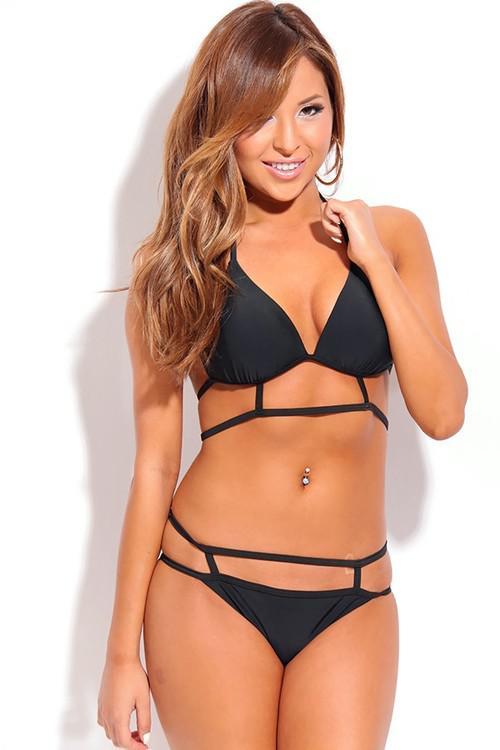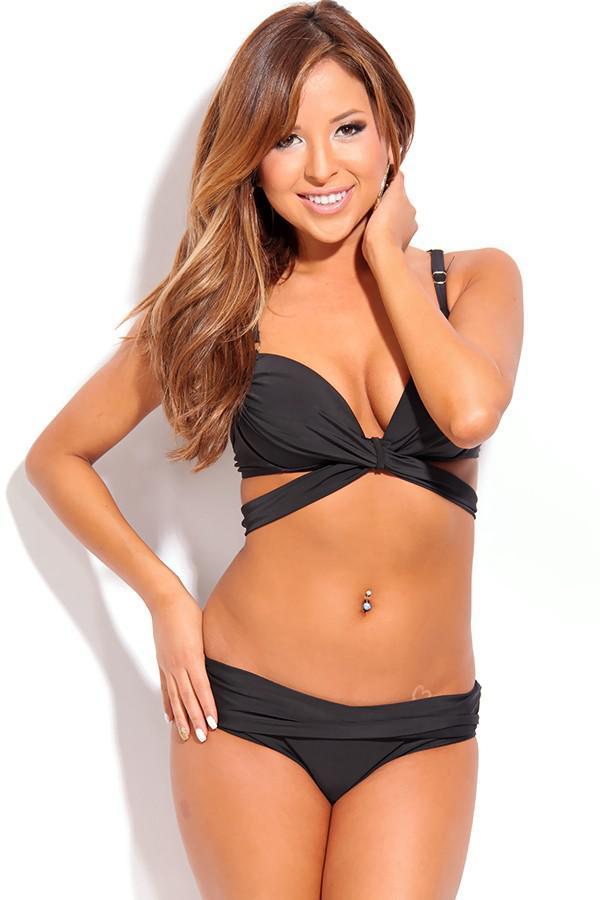The first image is the image on the left, the second image is the image on the right. Evaluate the accuracy of this statement regarding the images: "One of the images shows a woman near a swimming pool.". Is it true? Answer yes or no. No. The first image is the image on the left, the second image is the image on the right. For the images shown, is this caption "All bikinis shown are solid black." true? Answer yes or no. Yes. 